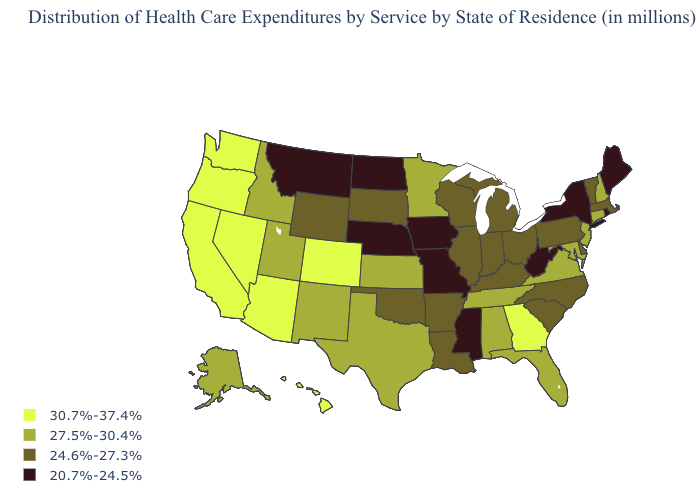What is the value of Colorado?
Answer briefly. 30.7%-37.4%. Which states hav the highest value in the South?
Keep it brief. Georgia. What is the lowest value in the West?
Give a very brief answer. 20.7%-24.5%. Name the states that have a value in the range 20.7%-24.5%?
Answer briefly. Iowa, Maine, Mississippi, Missouri, Montana, Nebraska, New York, North Dakota, Rhode Island, West Virginia. What is the value of Pennsylvania?
Keep it brief. 24.6%-27.3%. Name the states that have a value in the range 27.5%-30.4%?
Quick response, please. Alabama, Alaska, Connecticut, Florida, Idaho, Kansas, Maryland, Minnesota, New Hampshire, New Jersey, New Mexico, Tennessee, Texas, Utah, Virginia. Name the states that have a value in the range 27.5%-30.4%?
Keep it brief. Alabama, Alaska, Connecticut, Florida, Idaho, Kansas, Maryland, Minnesota, New Hampshire, New Jersey, New Mexico, Tennessee, Texas, Utah, Virginia. What is the highest value in the USA?
Write a very short answer. 30.7%-37.4%. How many symbols are there in the legend?
Keep it brief. 4. Name the states that have a value in the range 20.7%-24.5%?
Write a very short answer. Iowa, Maine, Mississippi, Missouri, Montana, Nebraska, New York, North Dakota, Rhode Island, West Virginia. How many symbols are there in the legend?
Keep it brief. 4. Name the states that have a value in the range 24.6%-27.3%?
Be succinct. Arkansas, Delaware, Illinois, Indiana, Kentucky, Louisiana, Massachusetts, Michigan, North Carolina, Ohio, Oklahoma, Pennsylvania, South Carolina, South Dakota, Vermont, Wisconsin, Wyoming. What is the lowest value in the USA?
Quick response, please. 20.7%-24.5%. Does Washington have the highest value in the USA?
Answer briefly. Yes. What is the lowest value in states that border Maine?
Give a very brief answer. 27.5%-30.4%. 